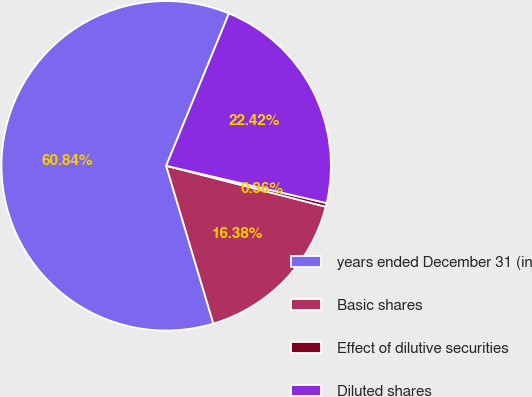<chart> <loc_0><loc_0><loc_500><loc_500><pie_chart><fcel>years ended December 31 (in<fcel>Basic shares<fcel>Effect of dilutive securities<fcel>Diluted shares<nl><fcel>60.84%<fcel>16.38%<fcel>0.36%<fcel>22.42%<nl></chart> 